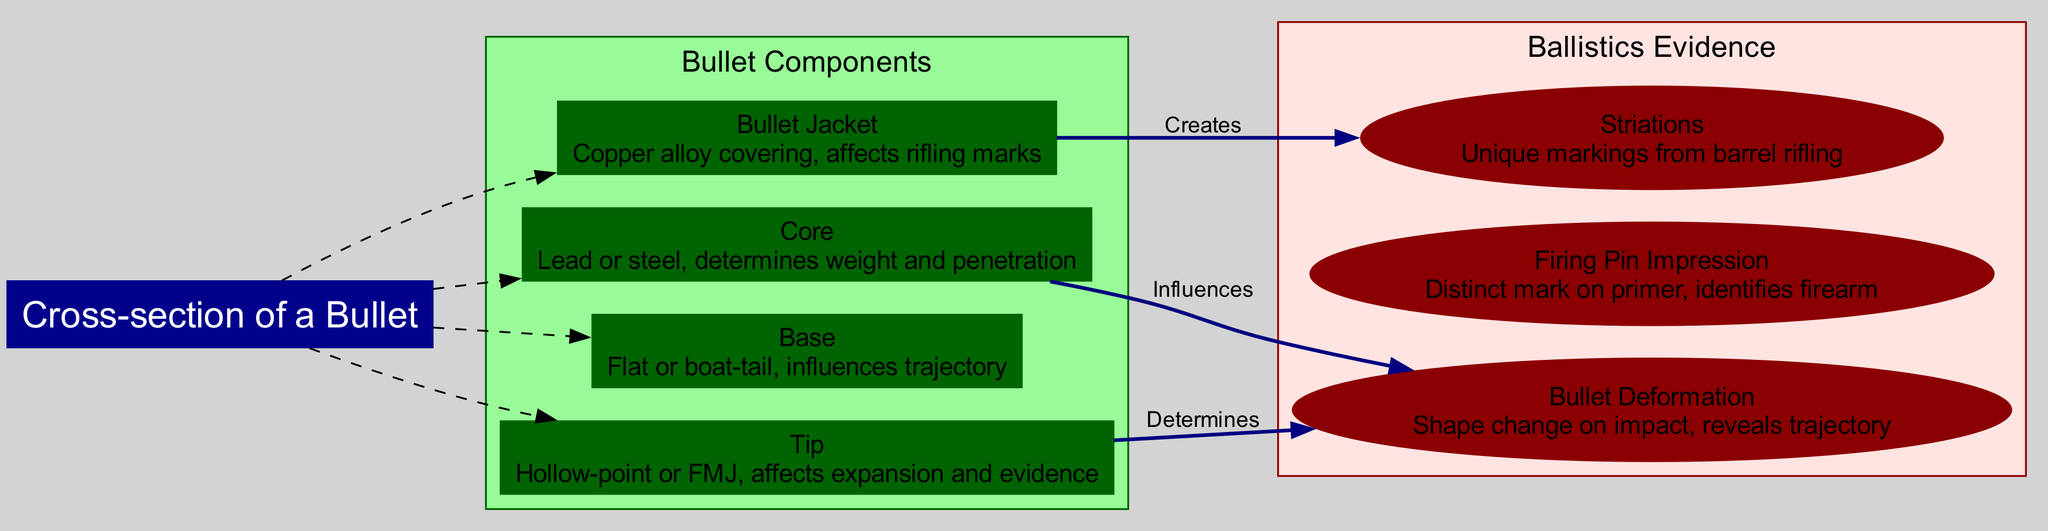What is the central topic of the diagram? The central topic node clearly indicates that the diagram is focused on the "Cross-section of a Bullet," which is the main subject being illustrated.
Answer: Cross-section of a Bullet How many components are shown in the diagram? The diagram includes a cluster for bullet components with four nodes: Bullet Jacket, Core, Base, and Tip. Counting these nodes gives a total of four components.
Answer: 4 What type of marking does the Bullet Jacket create? The connections indicate that the Bullet Jacket "Creates" Striations, which are unique markings resulting from the rifling in a firearm's barrel.
Answer: Striations What influences Bullet Deformation according to the diagram? The diagram shows connections where both the Core and the Tip influence Bullet Deformation. Specifically, the Core influences it and the Tip determines it as indicated by the labels on the edges.
Answer: Core and Tip What is the effect of the Tip on ballistics evidence? Based on the diagram, the Tip "Determines" Bullet Deformation, which implies that its design (e.g., hollow-point or FMJ) directly affects how a bullet deforms upon impact, influencing evidence collected at a crime scene.
Answer: Determines Bullet Deformation What are the two components that affect Bullet Deformation? The diagram highlights connections indicating that both the Core and the Tip influence aspects of Bullet Deformation, making them pivotal components in determining how a bullet behaves on impact.
Answer: Core and Tip What type of mark does the Firing Pin Impression provide? The diagram states that the Firing Pin Impression creates a distinct mark on the primer, which serves to identify the specific firearm used in a shooting incident.
Answer: Distinct mark on primer How many types of ballistics evidence are present in the diagram? The ballistics evidence section contains three distinct types of evidence: Striations, Firing Pin Impression, and Bullet Deformation, giving a total of three types.
Answer: 3 Which component is responsible for creating unique markings on the bullet? The diagram connects the Bullet Jacket to Striations, indicating that the bullet jacket creates unique markings that are a critical element of ballistic evidence.
Answer: Bullet Jacket 